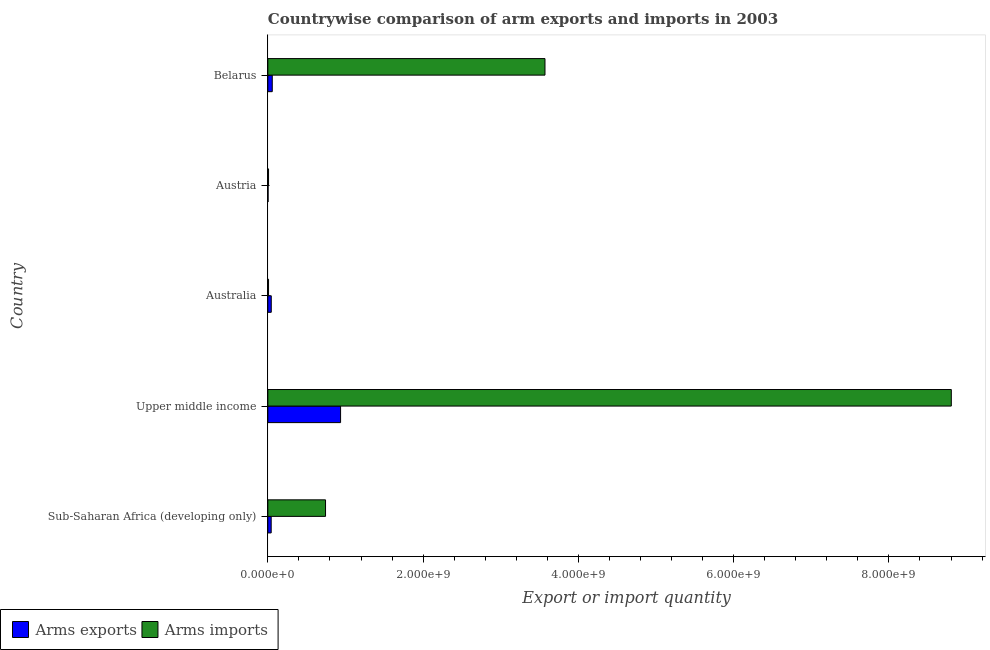How many groups of bars are there?
Give a very brief answer. 5. Are the number of bars on each tick of the Y-axis equal?
Provide a short and direct response. Yes. How many bars are there on the 2nd tick from the bottom?
Provide a succinct answer. 2. What is the label of the 4th group of bars from the top?
Offer a terse response. Upper middle income. In how many cases, is the number of bars for a given country not equal to the number of legend labels?
Provide a succinct answer. 0. What is the arms exports in Belarus?
Your answer should be compact. 5.70e+07. Across all countries, what is the maximum arms imports?
Your answer should be very brief. 8.80e+09. Across all countries, what is the minimum arms imports?
Make the answer very short. 9.00e+06. In which country was the arms exports maximum?
Make the answer very short. Upper middle income. What is the total arms exports in the graph?
Offer a very short reply. 1.08e+09. What is the difference between the arms imports in Austria and that in Belarus?
Offer a terse response. -3.56e+09. What is the difference between the arms imports in Austria and the arms exports in Sub-Saharan Africa (developing only)?
Your response must be concise. -3.40e+07. What is the average arms imports per country?
Your answer should be very brief. 2.63e+09. What is the difference between the arms exports and arms imports in Austria?
Provide a short and direct response. -6.00e+06. What is the ratio of the arms exports in Sub-Saharan Africa (developing only) to that in Upper middle income?
Your answer should be compact. 0.05. What is the difference between the highest and the second highest arms imports?
Ensure brevity in your answer.  5.23e+09. What is the difference between the highest and the lowest arms exports?
Your answer should be very brief. 9.34e+08. What does the 2nd bar from the top in Sub-Saharan Africa (developing only) represents?
Your response must be concise. Arms exports. What does the 2nd bar from the bottom in Upper middle income represents?
Your response must be concise. Arms imports. How many bars are there?
Keep it short and to the point. 10. Are the values on the major ticks of X-axis written in scientific E-notation?
Your response must be concise. Yes. Does the graph contain any zero values?
Your answer should be compact. No. Does the graph contain grids?
Make the answer very short. No. What is the title of the graph?
Keep it short and to the point. Countrywise comparison of arm exports and imports in 2003. What is the label or title of the X-axis?
Make the answer very short. Export or import quantity. What is the Export or import quantity of Arms exports in Sub-Saharan Africa (developing only)?
Your answer should be compact. 4.30e+07. What is the Export or import quantity of Arms imports in Sub-Saharan Africa (developing only)?
Give a very brief answer. 7.43e+08. What is the Export or import quantity of Arms exports in Upper middle income?
Make the answer very short. 9.37e+08. What is the Export or import quantity of Arms imports in Upper middle income?
Your answer should be very brief. 8.80e+09. What is the Export or import quantity of Arms exports in Australia?
Keep it short and to the point. 4.40e+07. What is the Export or import quantity of Arms imports in Australia?
Your answer should be compact. 9.00e+06. What is the Export or import quantity in Arms exports in Austria?
Offer a terse response. 3.00e+06. What is the Export or import quantity in Arms imports in Austria?
Make the answer very short. 9.00e+06. What is the Export or import quantity in Arms exports in Belarus?
Offer a terse response. 5.70e+07. What is the Export or import quantity in Arms imports in Belarus?
Offer a terse response. 3.57e+09. Across all countries, what is the maximum Export or import quantity in Arms exports?
Keep it short and to the point. 9.37e+08. Across all countries, what is the maximum Export or import quantity in Arms imports?
Make the answer very short. 8.80e+09. Across all countries, what is the minimum Export or import quantity in Arms imports?
Ensure brevity in your answer.  9.00e+06. What is the total Export or import quantity of Arms exports in the graph?
Make the answer very short. 1.08e+09. What is the total Export or import quantity of Arms imports in the graph?
Your response must be concise. 1.31e+1. What is the difference between the Export or import quantity of Arms exports in Sub-Saharan Africa (developing only) and that in Upper middle income?
Offer a terse response. -8.94e+08. What is the difference between the Export or import quantity in Arms imports in Sub-Saharan Africa (developing only) and that in Upper middle income?
Provide a succinct answer. -8.06e+09. What is the difference between the Export or import quantity in Arms imports in Sub-Saharan Africa (developing only) and that in Australia?
Give a very brief answer. 7.34e+08. What is the difference between the Export or import quantity in Arms exports in Sub-Saharan Africa (developing only) and that in Austria?
Ensure brevity in your answer.  4.00e+07. What is the difference between the Export or import quantity in Arms imports in Sub-Saharan Africa (developing only) and that in Austria?
Offer a terse response. 7.34e+08. What is the difference between the Export or import quantity in Arms exports in Sub-Saharan Africa (developing only) and that in Belarus?
Your answer should be very brief. -1.40e+07. What is the difference between the Export or import quantity of Arms imports in Sub-Saharan Africa (developing only) and that in Belarus?
Provide a succinct answer. -2.83e+09. What is the difference between the Export or import quantity in Arms exports in Upper middle income and that in Australia?
Keep it short and to the point. 8.93e+08. What is the difference between the Export or import quantity in Arms imports in Upper middle income and that in Australia?
Provide a succinct answer. 8.80e+09. What is the difference between the Export or import quantity in Arms exports in Upper middle income and that in Austria?
Your answer should be very brief. 9.34e+08. What is the difference between the Export or import quantity of Arms imports in Upper middle income and that in Austria?
Give a very brief answer. 8.80e+09. What is the difference between the Export or import quantity of Arms exports in Upper middle income and that in Belarus?
Ensure brevity in your answer.  8.80e+08. What is the difference between the Export or import quantity of Arms imports in Upper middle income and that in Belarus?
Your answer should be compact. 5.23e+09. What is the difference between the Export or import quantity of Arms exports in Australia and that in Austria?
Provide a succinct answer. 4.10e+07. What is the difference between the Export or import quantity in Arms exports in Australia and that in Belarus?
Provide a succinct answer. -1.30e+07. What is the difference between the Export or import quantity of Arms imports in Australia and that in Belarus?
Provide a succinct answer. -3.56e+09. What is the difference between the Export or import quantity in Arms exports in Austria and that in Belarus?
Ensure brevity in your answer.  -5.40e+07. What is the difference between the Export or import quantity in Arms imports in Austria and that in Belarus?
Give a very brief answer. -3.56e+09. What is the difference between the Export or import quantity in Arms exports in Sub-Saharan Africa (developing only) and the Export or import quantity in Arms imports in Upper middle income?
Provide a succinct answer. -8.76e+09. What is the difference between the Export or import quantity in Arms exports in Sub-Saharan Africa (developing only) and the Export or import quantity in Arms imports in Australia?
Keep it short and to the point. 3.40e+07. What is the difference between the Export or import quantity of Arms exports in Sub-Saharan Africa (developing only) and the Export or import quantity of Arms imports in Austria?
Provide a succinct answer. 3.40e+07. What is the difference between the Export or import quantity in Arms exports in Sub-Saharan Africa (developing only) and the Export or import quantity in Arms imports in Belarus?
Your response must be concise. -3.53e+09. What is the difference between the Export or import quantity of Arms exports in Upper middle income and the Export or import quantity of Arms imports in Australia?
Your answer should be very brief. 9.28e+08. What is the difference between the Export or import quantity of Arms exports in Upper middle income and the Export or import quantity of Arms imports in Austria?
Provide a succinct answer. 9.28e+08. What is the difference between the Export or import quantity in Arms exports in Upper middle income and the Export or import quantity in Arms imports in Belarus?
Your answer should be very brief. -2.63e+09. What is the difference between the Export or import quantity of Arms exports in Australia and the Export or import quantity of Arms imports in Austria?
Your response must be concise. 3.50e+07. What is the difference between the Export or import quantity of Arms exports in Australia and the Export or import quantity of Arms imports in Belarus?
Your answer should be compact. -3.53e+09. What is the difference between the Export or import quantity in Arms exports in Austria and the Export or import quantity in Arms imports in Belarus?
Ensure brevity in your answer.  -3.57e+09. What is the average Export or import quantity in Arms exports per country?
Your answer should be compact. 2.17e+08. What is the average Export or import quantity of Arms imports per country?
Provide a succinct answer. 2.63e+09. What is the difference between the Export or import quantity of Arms exports and Export or import quantity of Arms imports in Sub-Saharan Africa (developing only)?
Provide a short and direct response. -7.00e+08. What is the difference between the Export or import quantity in Arms exports and Export or import quantity in Arms imports in Upper middle income?
Your answer should be compact. -7.87e+09. What is the difference between the Export or import quantity in Arms exports and Export or import quantity in Arms imports in Australia?
Keep it short and to the point. 3.50e+07. What is the difference between the Export or import quantity in Arms exports and Export or import quantity in Arms imports in Austria?
Make the answer very short. -6.00e+06. What is the difference between the Export or import quantity in Arms exports and Export or import quantity in Arms imports in Belarus?
Give a very brief answer. -3.51e+09. What is the ratio of the Export or import quantity of Arms exports in Sub-Saharan Africa (developing only) to that in Upper middle income?
Offer a terse response. 0.05. What is the ratio of the Export or import quantity of Arms imports in Sub-Saharan Africa (developing only) to that in Upper middle income?
Your answer should be compact. 0.08. What is the ratio of the Export or import quantity of Arms exports in Sub-Saharan Africa (developing only) to that in Australia?
Provide a short and direct response. 0.98. What is the ratio of the Export or import quantity of Arms imports in Sub-Saharan Africa (developing only) to that in Australia?
Offer a terse response. 82.56. What is the ratio of the Export or import quantity in Arms exports in Sub-Saharan Africa (developing only) to that in Austria?
Offer a terse response. 14.33. What is the ratio of the Export or import quantity of Arms imports in Sub-Saharan Africa (developing only) to that in Austria?
Give a very brief answer. 82.56. What is the ratio of the Export or import quantity of Arms exports in Sub-Saharan Africa (developing only) to that in Belarus?
Provide a succinct answer. 0.75. What is the ratio of the Export or import quantity of Arms imports in Sub-Saharan Africa (developing only) to that in Belarus?
Give a very brief answer. 0.21. What is the ratio of the Export or import quantity of Arms exports in Upper middle income to that in Australia?
Give a very brief answer. 21.3. What is the ratio of the Export or import quantity of Arms imports in Upper middle income to that in Australia?
Offer a terse response. 978.22. What is the ratio of the Export or import quantity in Arms exports in Upper middle income to that in Austria?
Your answer should be very brief. 312.33. What is the ratio of the Export or import quantity of Arms imports in Upper middle income to that in Austria?
Keep it short and to the point. 978.22. What is the ratio of the Export or import quantity in Arms exports in Upper middle income to that in Belarus?
Your answer should be very brief. 16.44. What is the ratio of the Export or import quantity of Arms imports in Upper middle income to that in Belarus?
Your response must be concise. 2.47. What is the ratio of the Export or import quantity in Arms exports in Australia to that in Austria?
Make the answer very short. 14.67. What is the ratio of the Export or import quantity of Arms imports in Australia to that in Austria?
Offer a very short reply. 1. What is the ratio of the Export or import quantity in Arms exports in Australia to that in Belarus?
Make the answer very short. 0.77. What is the ratio of the Export or import quantity of Arms imports in Australia to that in Belarus?
Ensure brevity in your answer.  0. What is the ratio of the Export or import quantity of Arms exports in Austria to that in Belarus?
Keep it short and to the point. 0.05. What is the ratio of the Export or import quantity of Arms imports in Austria to that in Belarus?
Provide a succinct answer. 0. What is the difference between the highest and the second highest Export or import quantity of Arms exports?
Your answer should be compact. 8.80e+08. What is the difference between the highest and the second highest Export or import quantity in Arms imports?
Ensure brevity in your answer.  5.23e+09. What is the difference between the highest and the lowest Export or import quantity in Arms exports?
Provide a succinct answer. 9.34e+08. What is the difference between the highest and the lowest Export or import quantity in Arms imports?
Your answer should be compact. 8.80e+09. 